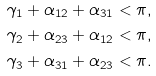Convert formula to latex. <formula><loc_0><loc_0><loc_500><loc_500>\gamma _ { 1 } + \alpha _ { 1 2 } + \alpha _ { 3 1 } & < \pi , \\ \gamma _ { 2 } + \alpha _ { 2 3 } + \alpha _ { 1 2 } & < \pi , \\ \gamma _ { 3 } + \alpha _ { 3 1 } + \alpha _ { 2 3 } & < \pi .</formula> 